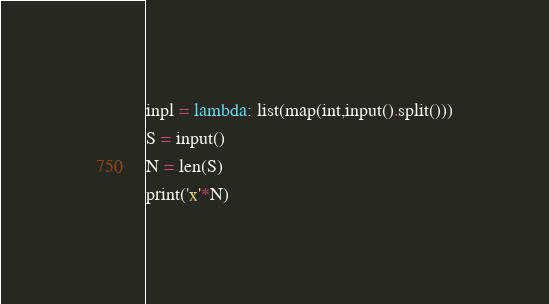Convert code to text. <code><loc_0><loc_0><loc_500><loc_500><_Python_>inpl = lambda: list(map(int,input().split()))
S = input()
N = len(S)
print('x'*N)</code> 